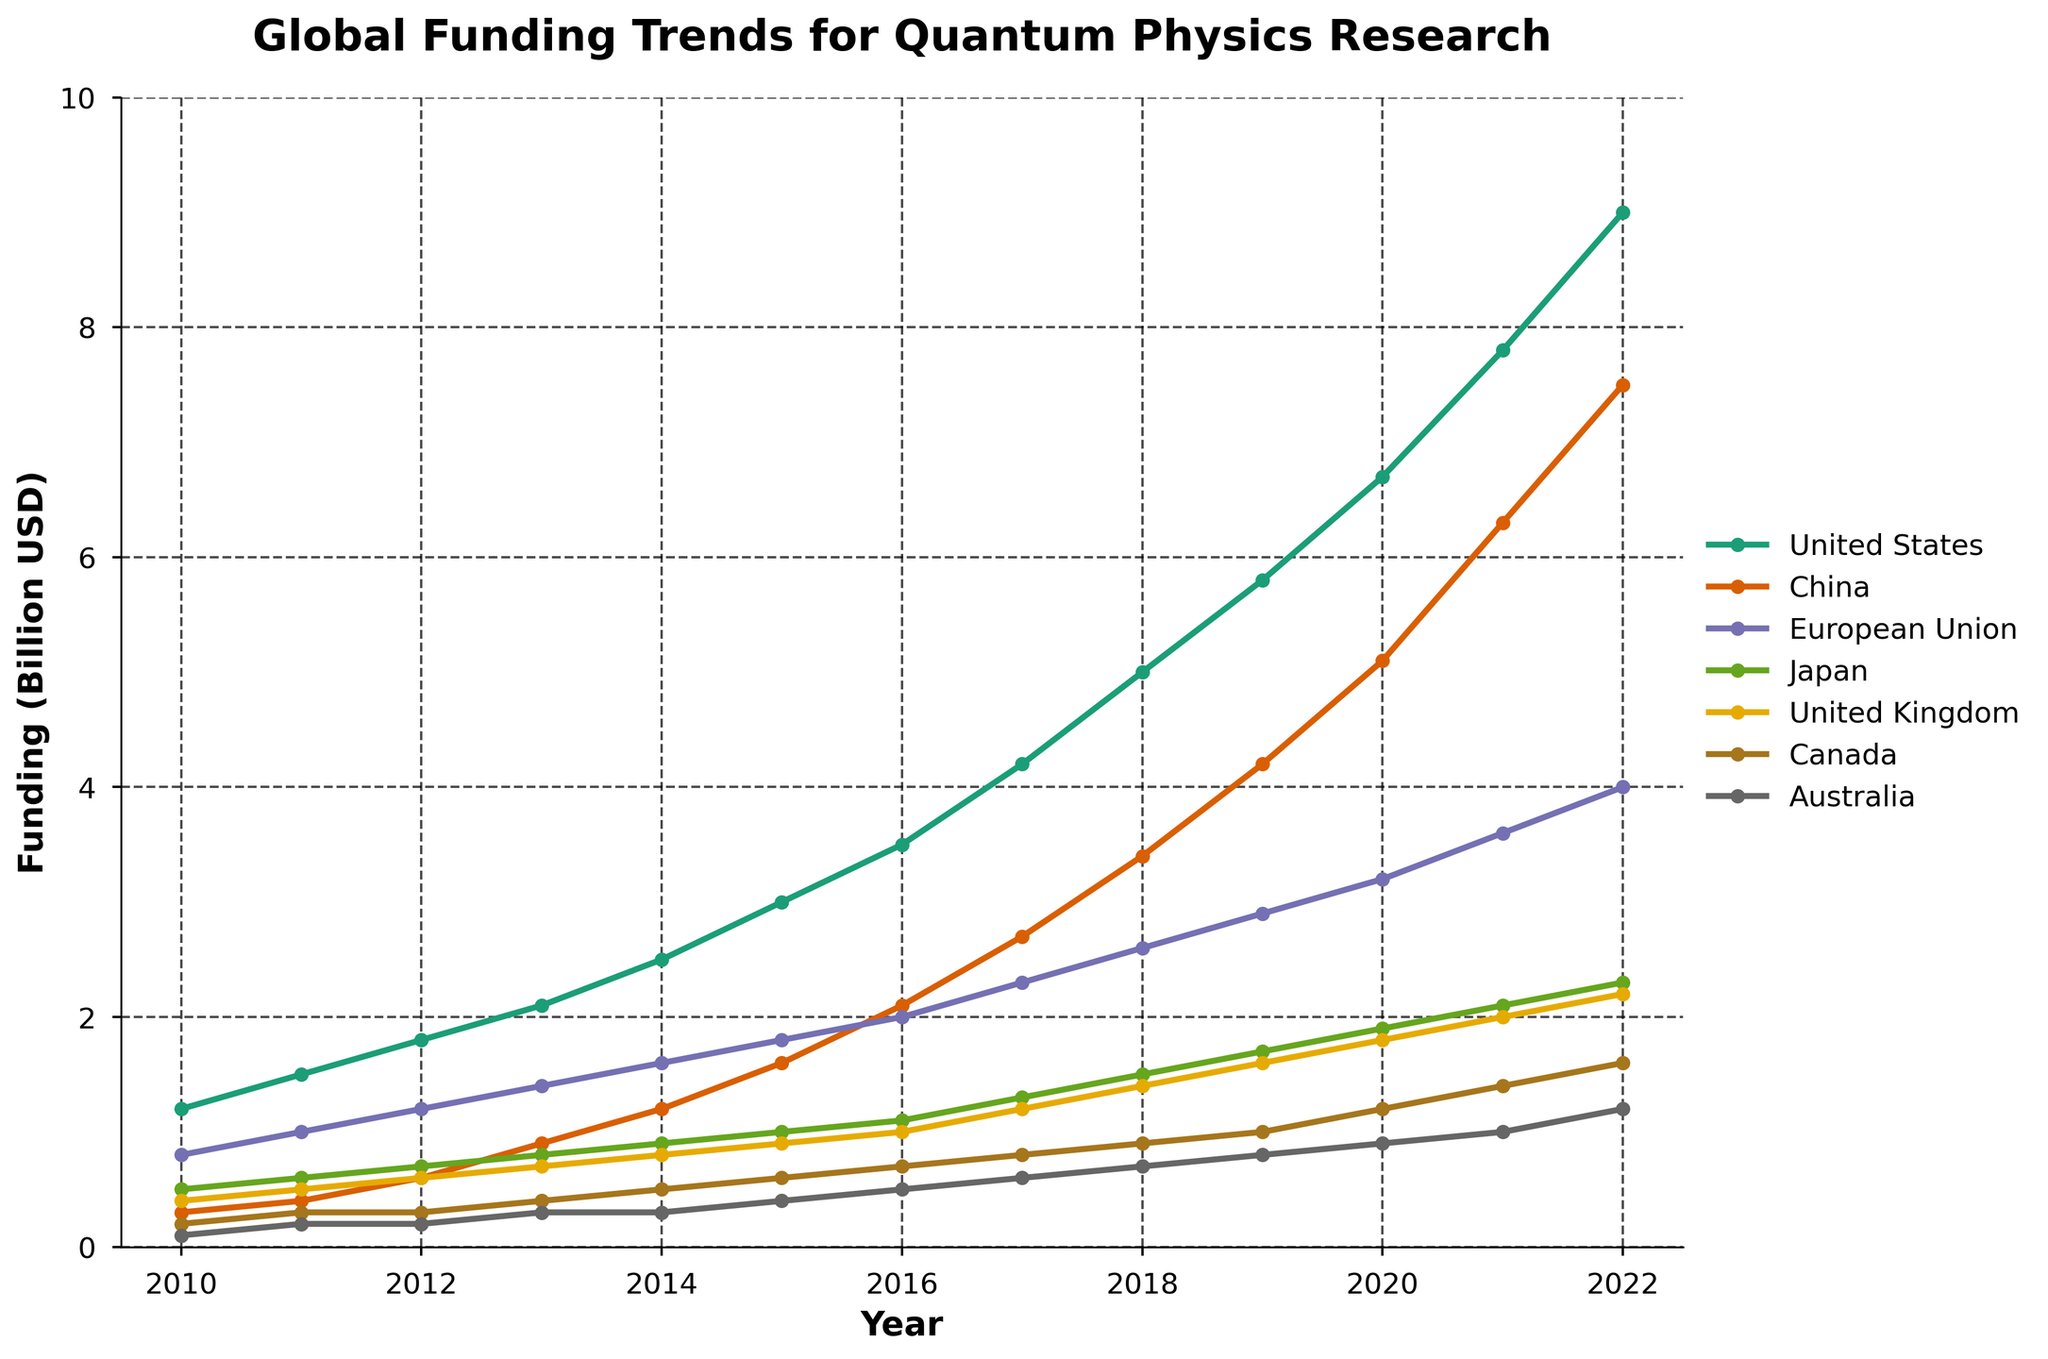Which country had the highest funding in 2022? Observe the plot and locate the country with the highest data point in 2022. The United States had the highest funding level at 9.0 billion USD.
Answer: The United States How did the funding in China compare to the UK in 2016? Compare the data points for China and the UK in 2016. China had 2.1 billion USD while the UK had 1.0 billion USD in funding.
Answer: China had more funding What is the trend of funding in Canada from 2010 to 2022? Observe the line for Canada from 2010 to 2022. The funding shows a steady increase from 0.2 to 1.6 billion USD.
Answer: Steady increase Which three years saw the highest funding increase in the United States? Calculate the yearly increases in funding for the United States and identify the three largest increases. The years 2020-2021, 2021-2022, and 2018-2019 saw the highest increases.
Answer: 2020-2021, 2021-2022, and 2018-2019 What is the average annual funding for quantum physics research in the European Union from 2010 to 2022? Sum all the yearly funding values for the European Union and divide by the number of years (13). (0.8 + 1.0 + 1.2 + 1.4 + 1.6 + 1.8 + 2.0 + 2.3 + 2.6 + 2.9 + 3.2 + 3.6 + 4.0) / 13 ≈ 2.207
Answer: 2.207 billion USD How did the funding change in Japan from 2012 to 2015 compared to Australia over the same period? Calculate the funding change for Japan (1.0 - 0.7 = 0.3 billion USD) and Australia (0.4 - 0.2 = 0.2 billion USD) from 2012 to 2015.
Answer: Japan increased by 0.3 billion USD, Australia by 0.2 billion USD Which country had the smallest funding in 2012? Identify the lowest data point among the countries in 2012. Australia had the smallest funding at 0.2 billion USD.
Answer: Australia By how much did the funding for China increase from 2017 to 2020? Subtract the funding in 2017 from the funding in 2020 for China. 5.1 - 2.7 = 2.4 billion USD.
Answer: 2.4 billion USD What was the difference in funding between the United States and the European Union in 2010? Subtract the European Union's funding from the United States' funding in 2010. 1.2 - 0.8 = 0.4 billion USD.
Answer: 0.4 billion USD 